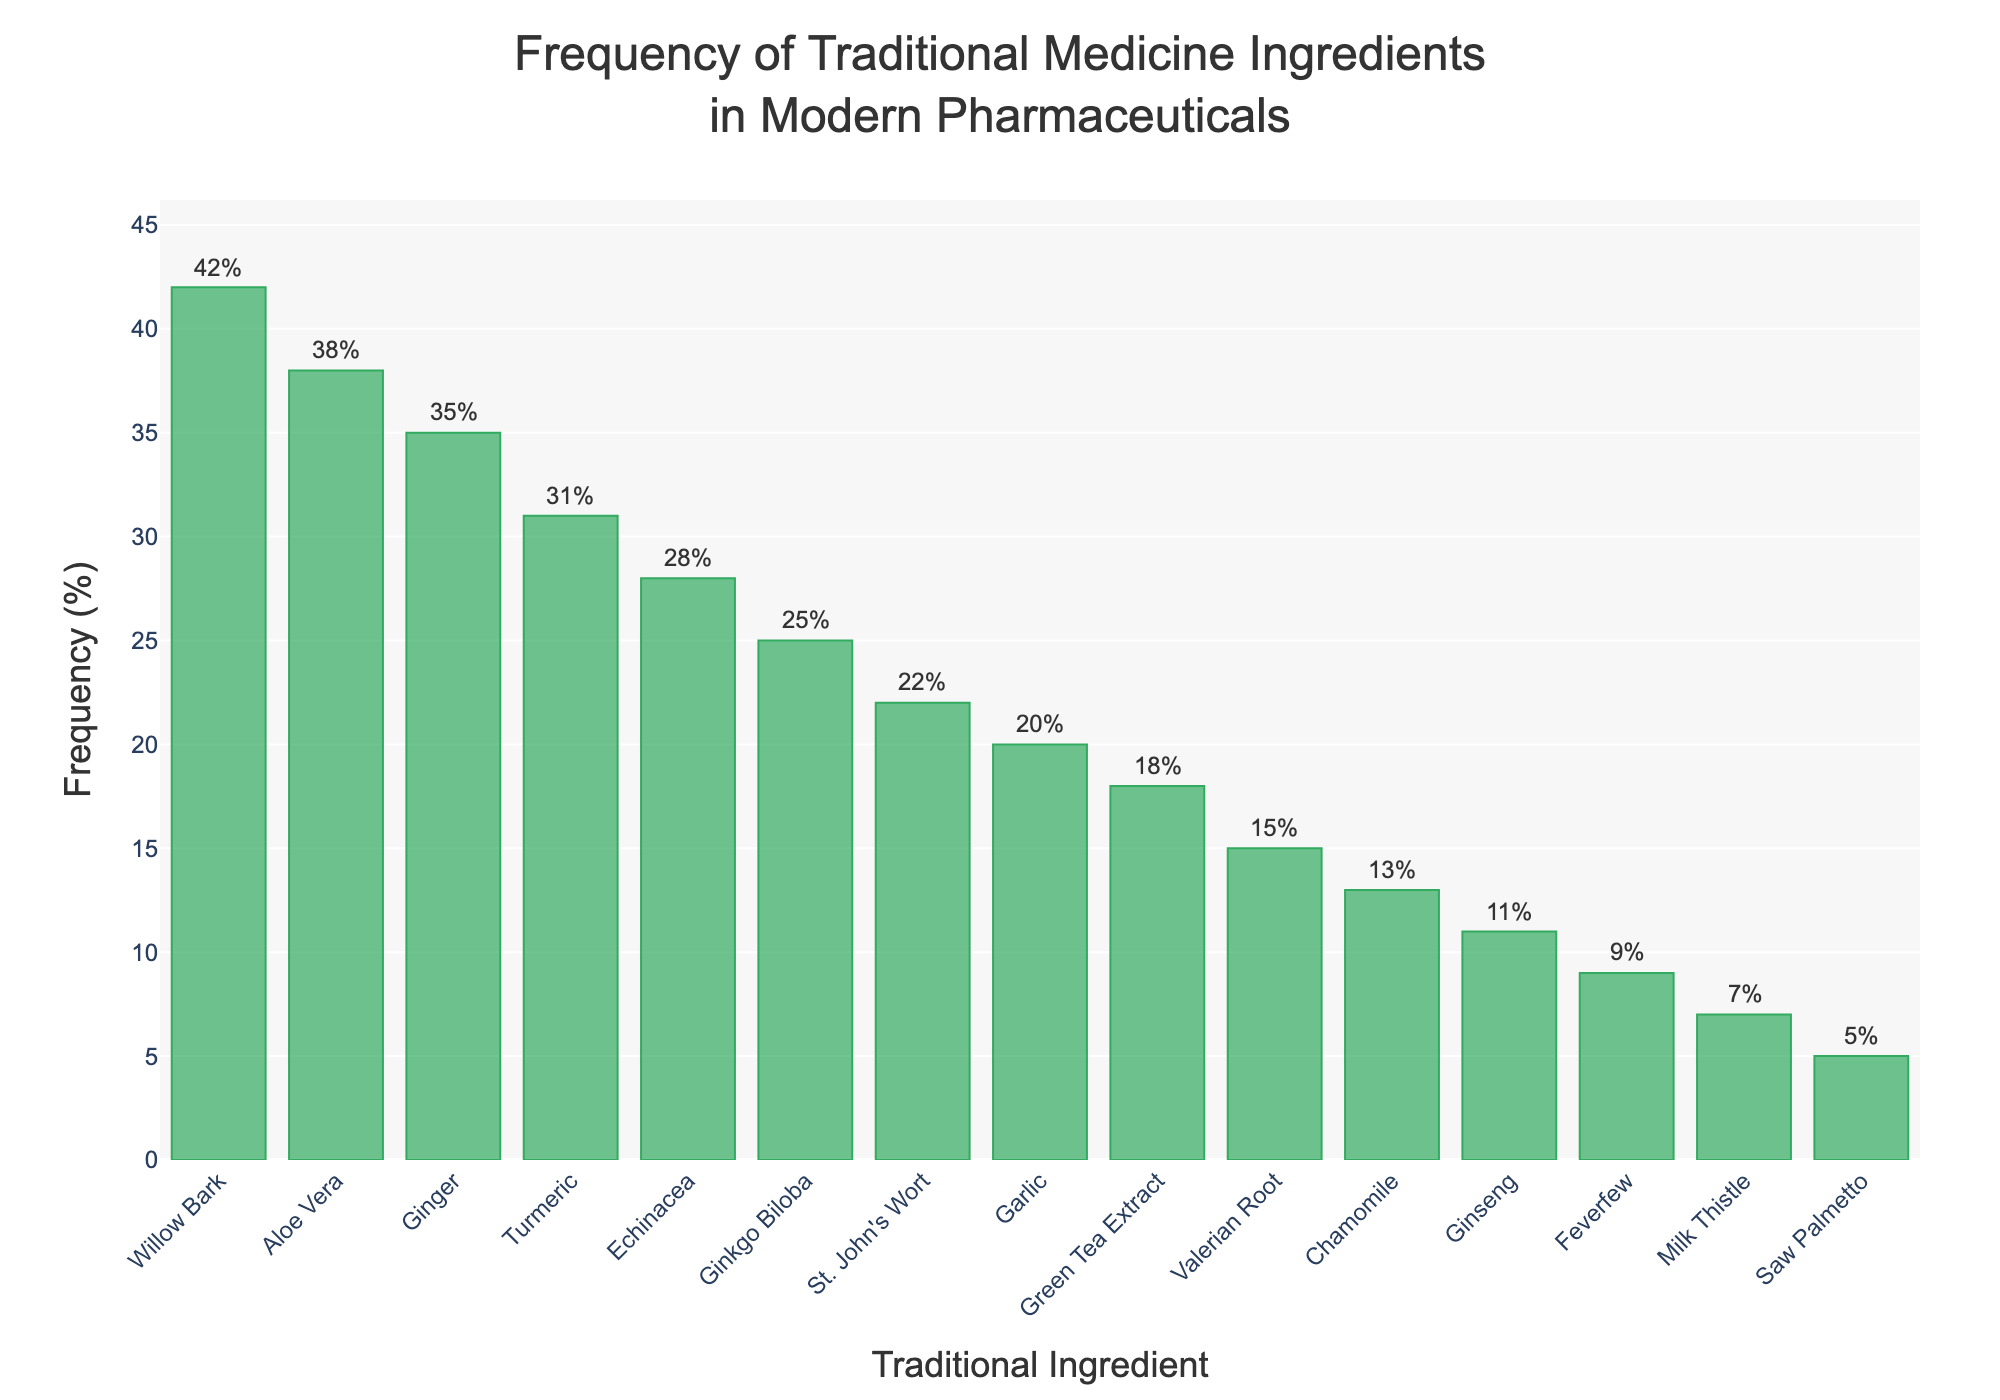What's the most frequent traditional ingredient in modern pharmaceuticals? The tallest bar in the figure represents the frequency of Willow Bark at 42%, making it the most used traditional ingredient in modern pharmaceuticals.
Answer: Willow Bark What's the total frequency of Aloe Vera and Ginger combined? To find the total frequency, add the frequency percentages of Aloe Vera (38%) and Ginger (35%). 38% + 35% = 73%.
Answer: 73% Which ingredient is used less frequently than Echinacea but more frequently than Garlic? By examining the bars, Echinacea's frequency is 28% and Garlic's is 20%. The bars between these two frequencies are Ginkgo Biloba (25%) and St. John's Wort (22%). Among these, Ginkgo Biloba is more frequent than St. John's Wort.
Answer: Ginkgo Biloba What's the average frequency of the top three traditional ingredients in modern pharmaceuticals? To calculate the average frequency of the top three ingredients, add Willow Bark (42%), Aloe Vera (38%), and Ginger (35%), then divide by 3. (42% + 38% + 35%) / 3 = 115% / 3 ≈ 38.33%.
Answer: 38.33% Which ingredient has a frequency of exactly 7%? By looking at the annotations and heights of the bars, Milk Thistle has a frequency of exactly 7%.
Answer: Milk Thistle How much higher is the usage of Willow Bark compared to Valerian Root? The frequency of Willow Bark is 42% and Valerian Root is 15%. The difference is 42% - 15% = 27%.
Answer: 27% Which has a greater frequency, Green Tea Extract or St. John's Wort? The bars for Green Tea Extract and St. John's Wort show frequencies of 18% and 22% respectively. St. John's Wort is greater.
Answer: St. John's Wort What is the combined frequency of all ingredients above 30%? Identify the ingredients above 30%: Willow Bark (42%), Aloe Vera (38%), Ginger (35%), and Turmeric (31%). Add their frequencies: 42% + 38% + 35% + 31% = 146%.
Answer: 146% What is the median frequency of all the traditional ingredients listed? To find the median, list all frequencies in ascending order: 5%, 7%, 9%, 11%, 13%, 15%, 18%, 20%, 22%, 25%, 28%, 31%, 35%, 38%, 42%. With 15 data points, the median is the 8th value, which is 20%.
Answer: 20% Which traditional ingredient is the least used in modern pharmaceuticals? The shortest bar in the figure represents the frequency of Saw Palmetto at 5%, making it the least used traditional ingredient.
Answer: Saw Palmetto 